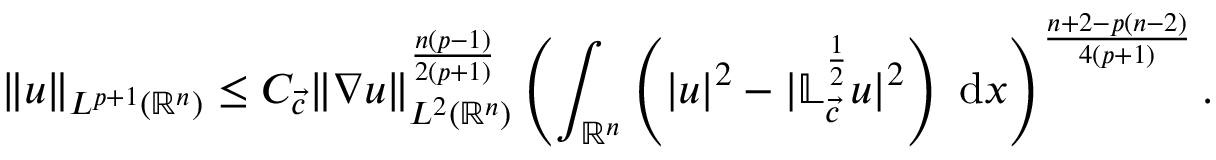<formula> <loc_0><loc_0><loc_500><loc_500>\| u \| _ { L ^ { p + 1 } ( { \mathbb { R } ^ { n } } ) } \leq C _ { { \vec { c } } } \| \nabla u \| _ { L ^ { 2 } ( { \mathbb { R } ^ { n } } ) } ^ { \frac { n ( p - 1 ) } { 2 ( p + 1 ) } } \left ( \int _ { \mathbb { R } ^ { n } } \left ( | u | ^ { 2 } - | \mathbb { L } _ { \vec { c } } ^ { \frac { 1 } { 2 } } u | ^ { 2 } \right ) \, d x \right ) ^ { \frac { n + 2 - p ( n - 2 ) } { 4 ( p + 1 ) } } .</formula> 